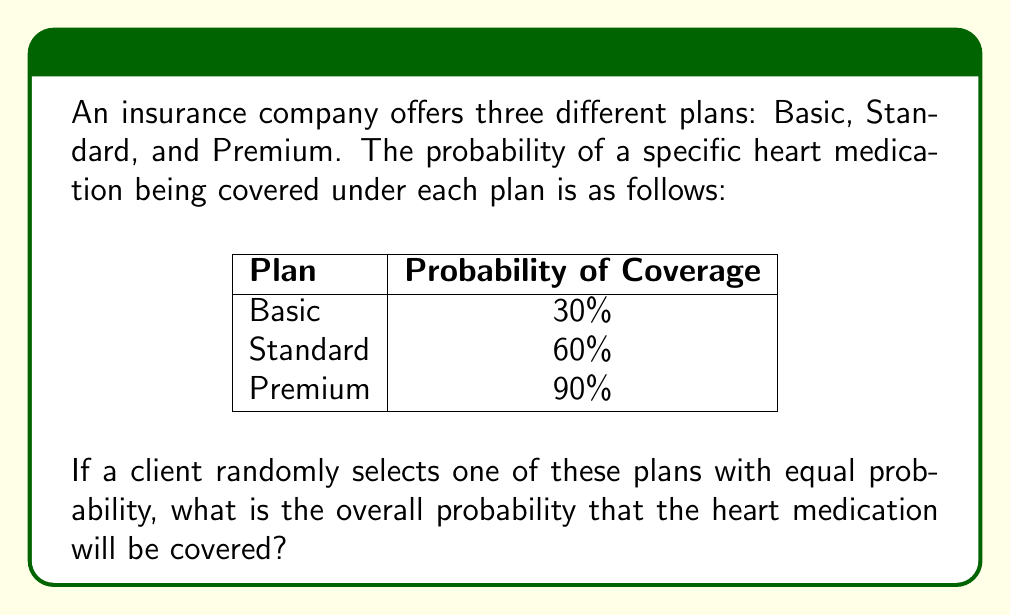Show me your answer to this math problem. Let's approach this step-by-step:

1) First, we need to understand that this is a problem of total probability. We need to consider all possible outcomes (plans) and their respective probabilities of coverage.

2) The probability of selecting each plan is equal, which means:
   $P(\text{Basic}) = P(\text{Standard}) = P(\text{Premium}) = \frac{1}{3}$

3) Now, let's define our events:
   A: The medication is covered
   B: Basic plan is selected
   S: Standard plan is selected
   P: Premium plan is selected

4) We can use the law of total probability:
   $P(A) = P(A|B)P(B) + P(A|S)P(S) + P(A|P)P(P)$

5) Substituting the values:
   $P(A) = 0.30 \cdot \frac{1}{3} + 0.60 \cdot \frac{1}{3} + 0.90 \cdot \frac{1}{3}$

6) Simplifying:
   $P(A) = \frac{0.30 + 0.60 + 0.90}{3} = \frac{1.80}{3} = 0.60$

Therefore, the overall probability that the heart medication will be covered is 0.60 or 60%.
Answer: 0.60 or 60% 